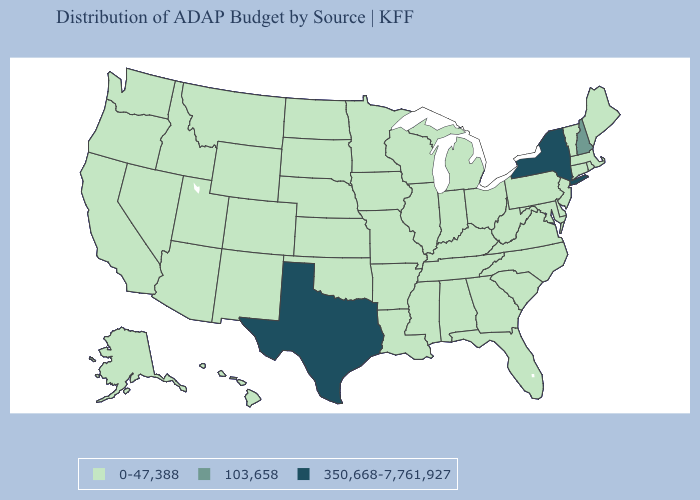Name the states that have a value in the range 103,658?
Give a very brief answer. New Hampshire. Name the states that have a value in the range 350,668-7,761,927?
Be succinct. New York, Texas. Among the states that border Michigan , which have the lowest value?
Be succinct. Indiana, Ohio, Wisconsin. What is the value of Kansas?
Be succinct. 0-47,388. What is the value of Iowa?
Answer briefly. 0-47,388. What is the highest value in the USA?
Be succinct. 350,668-7,761,927. What is the value of Virginia?
Concise answer only. 0-47,388. What is the value of Tennessee?
Concise answer only. 0-47,388. Does Kentucky have a higher value than Wyoming?
Be succinct. No. Among the states that border Alabama , which have the lowest value?
Quick response, please. Florida, Georgia, Mississippi, Tennessee. Does New York have the lowest value in the Northeast?
Write a very short answer. No. What is the value of Louisiana?
Keep it brief. 0-47,388. What is the value of Indiana?
Give a very brief answer. 0-47,388. 